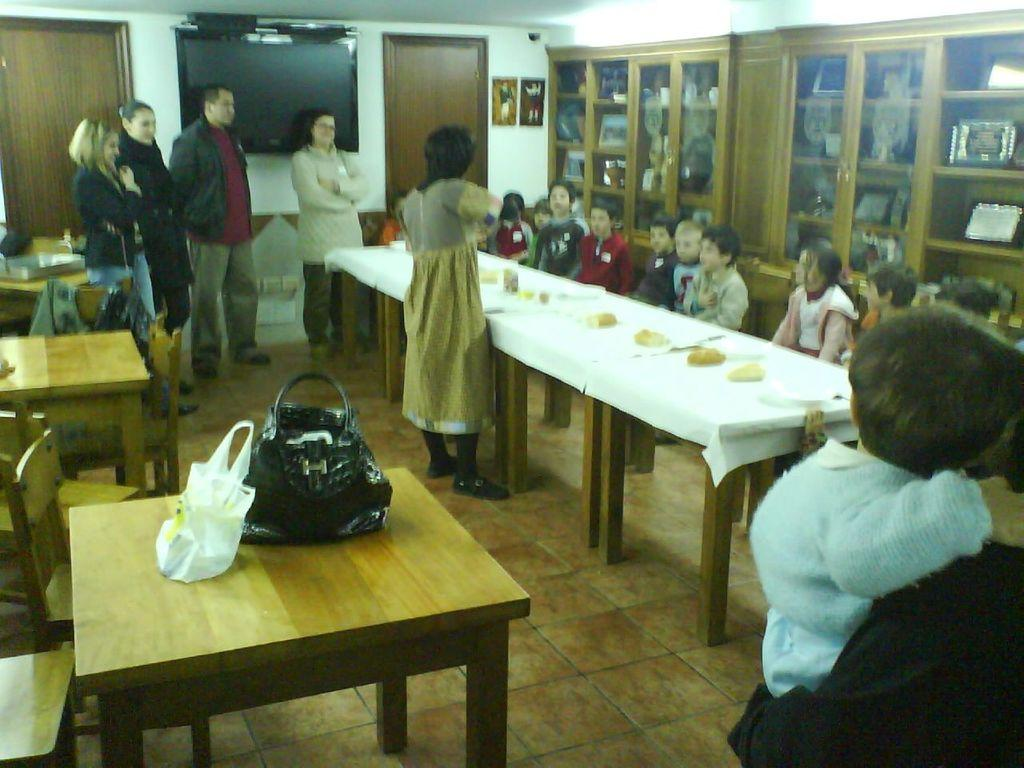What is the main subject of the image? The main subject of the image is a group of children. How are the children positioned in the image? The children are sitting in a chair. What is in front of the children? There is a table in front of the children. What else can be seen in the image? There is a group of people standing in front of the children. How does the water affect the hot experience in the image? There is no water or hot experience present in the image; it features a group of children sitting in a chair with a table in front of them and a group of people standing in front of them. 